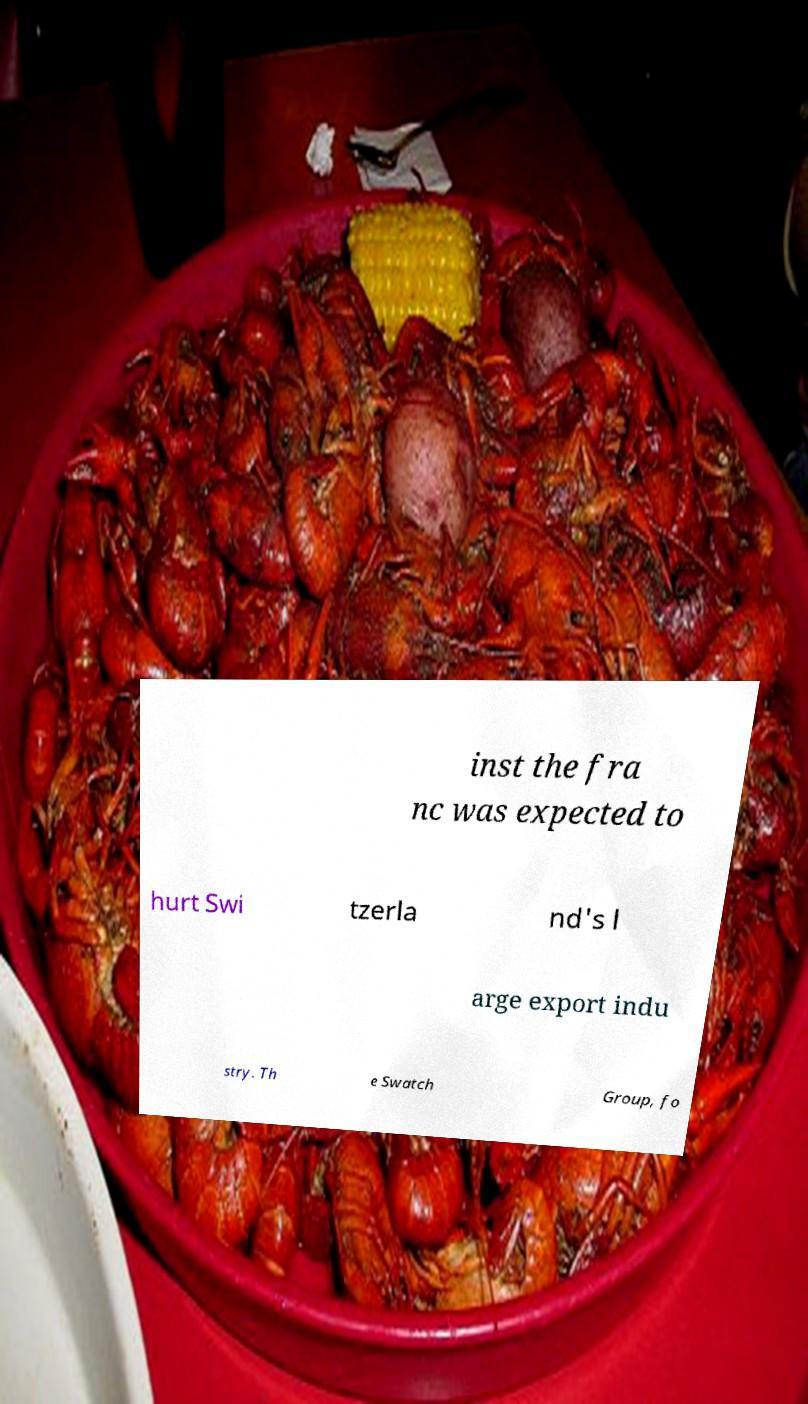Can you read and provide the text displayed in the image?This photo seems to have some interesting text. Can you extract and type it out for me? inst the fra nc was expected to hurt Swi tzerla nd's l arge export indu stry. Th e Swatch Group, fo 